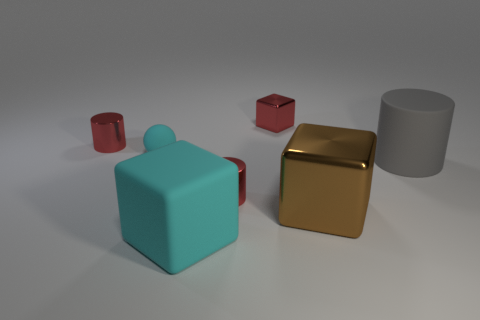Are there any other things that are the same color as the small cube?
Your answer should be very brief. Yes. There is another tiny object that is the same shape as the brown metal object; what color is it?
Your answer should be compact. Red. There is a rubber object that is the same color as the small matte sphere; what is its shape?
Offer a terse response. Cube. There is a cyan rubber object that is in front of the sphere; does it have the same shape as the large shiny object?
Your answer should be compact. Yes. There is a rubber object that is the same color as the tiny matte ball; what size is it?
Your response must be concise. Large. There is a tiny red cylinder that is behind the big rubber cylinder that is on the right side of the cyan matte ball; what is it made of?
Offer a very short reply. Metal. There is a red shiny cylinder that is on the right side of the cyan matte thing that is in front of the tiny cylinder that is to the right of the small cyan object; how big is it?
Your response must be concise. Small. How many gray objects are the same material as the large cyan block?
Provide a succinct answer. 1. The big rubber thing that is in front of the shiny cube in front of the gray cylinder is what color?
Provide a succinct answer. Cyan. How many objects are tiny matte balls or tiny red objects in front of the large cylinder?
Keep it short and to the point. 2. 